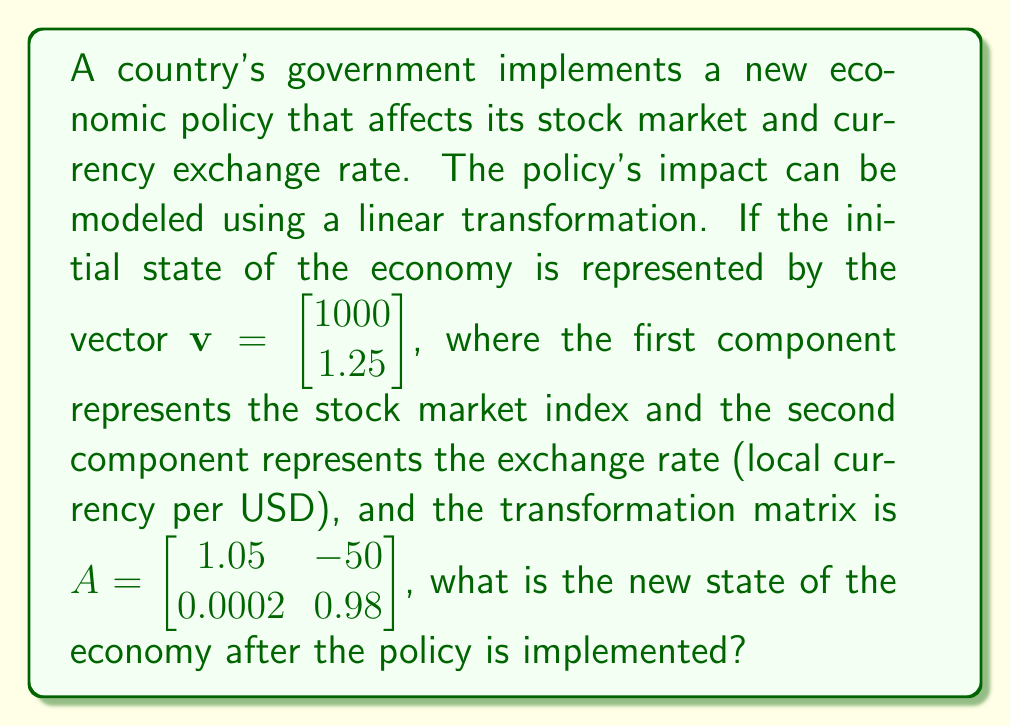Teach me how to tackle this problem. To find the new state of the economy after the policy is implemented, we need to apply the linear transformation represented by matrix $A$ to the initial state vector $\mathbf{v}$. This is done by multiplying $A$ and $\mathbf{v}$.

Let $\mathbf{w}$ be the resulting vector after the transformation:

$$\mathbf{w} = A\mathbf{v}$$

Step 1: Multiply matrix $A$ by vector $\mathbf{v}$:

$$\mathbf{w} = \begin{bmatrix} 1.05 & -50 \\ 0.0002 & 0.98 \end{bmatrix} \begin{bmatrix} 1000 \\ 1.25 \end{bmatrix}$$

Step 2: Perform the matrix multiplication:

$$\mathbf{w} = \begin{bmatrix} (1.05 \times 1000) + (-50 \times 1.25) \\ (0.0002 \times 1000) + (0.98 \times 1.25) \end{bmatrix}$$

Step 3: Calculate the components:

$$\mathbf{w} = \begin{bmatrix} 1050 - 62.5 \\ 0.2 + 1.225 \end{bmatrix}$$

Step 4: Simplify:

$$\mathbf{w} = \begin{bmatrix} 987.5 \\ 1.425 \end{bmatrix}$$

The resulting vector $\mathbf{w}$ represents the new state of the economy after the policy is implemented.
Answer: $\begin{bmatrix} 987.5 \\ 1.425 \end{bmatrix}$ 